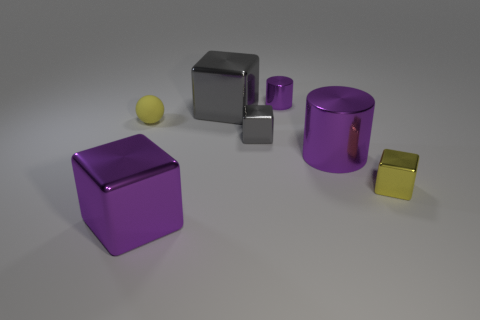Subtract all tiny yellow metallic cubes. How many cubes are left? 3 Subtract 2 cubes. How many cubes are left? 2 Subtract all purple cubes. How many cubes are left? 3 Add 2 tiny gray objects. How many objects exist? 9 Subtract all green cubes. Subtract all brown balls. How many cubes are left? 4 Subtract all cylinders. How many objects are left? 5 Add 7 large purple cubes. How many large purple cubes are left? 8 Add 5 large metal cylinders. How many large metal cylinders exist? 6 Subtract 0 cyan spheres. How many objects are left? 7 Subtract all purple shiny objects. Subtract all small cylinders. How many objects are left? 3 